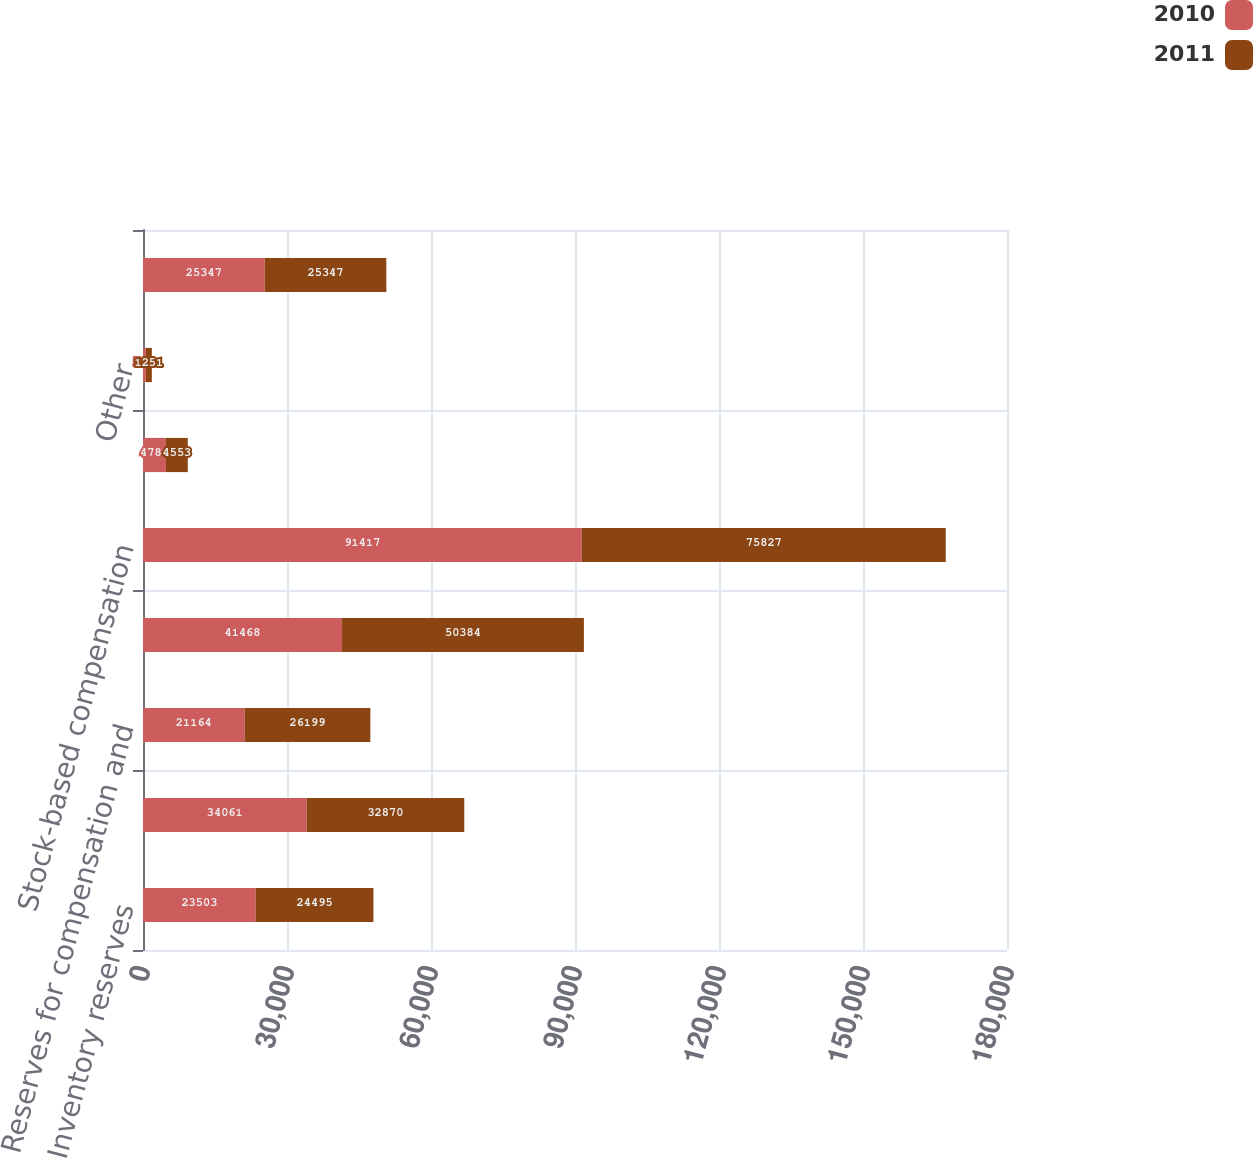<chart> <loc_0><loc_0><loc_500><loc_500><stacked_bar_chart><ecel><fcel>Inventory reserves<fcel>Deferred income on shipments<fcel>Reserves for compensation and<fcel>Tax credit carryovers<fcel>Stock-based compensation<fcel>Depreciation<fcel>Other<fcel>Total gross deferred tax<nl><fcel>2010<fcel>23503<fcel>34061<fcel>21164<fcel>41468<fcel>91417<fcel>4781<fcel>592<fcel>25347<nl><fcel>2011<fcel>24495<fcel>32870<fcel>26199<fcel>50384<fcel>75827<fcel>4553<fcel>1251<fcel>25347<nl></chart> 